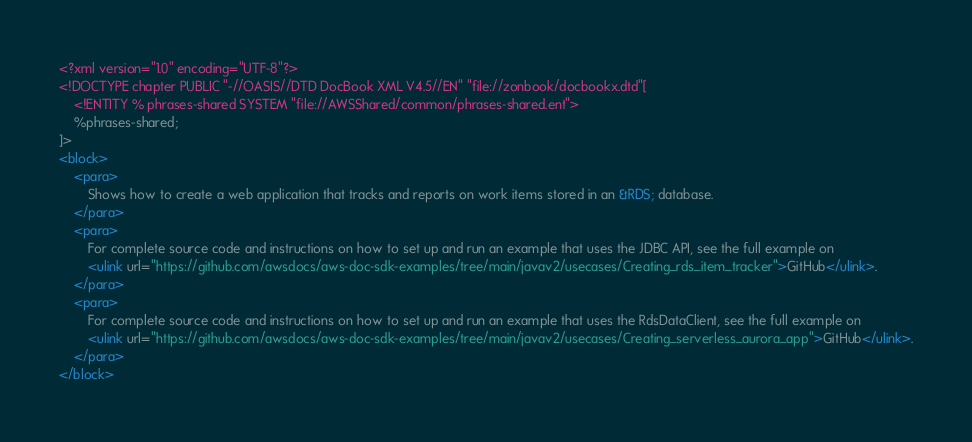<code> <loc_0><loc_0><loc_500><loc_500><_XML_><?xml version="1.0" encoding="UTF-8"?>
<!DOCTYPE chapter PUBLIC "-//OASIS//DTD DocBook XML V4.5//EN" "file://zonbook/docbookx.dtd"[
    <!ENTITY % phrases-shared SYSTEM "file://AWSShared/common/phrases-shared.ent">
    %phrases-shared;
]>
<block>
    <para>
        Shows how to create a web application that tracks and reports on work items stored in an &RDS; database. 
    </para>
    <para>
        For complete source code and instructions on how to set up and run an example that uses the JDBC API, see the full example on
        <ulink url="https://github.com/awsdocs/aws-doc-sdk-examples/tree/main/javav2/usecases/Creating_rds_item_tracker">GitHub</ulink>.
    </para>
    <para>
        For complete source code and instructions on how to set up and run an example that uses the RdsDataClient, see the full example on
        <ulink url="https://github.com/awsdocs/aws-doc-sdk-examples/tree/main/javav2/usecases/Creating_serverless_aurora_app">GitHub</ulink>.
    </para>
</block>
</code> 